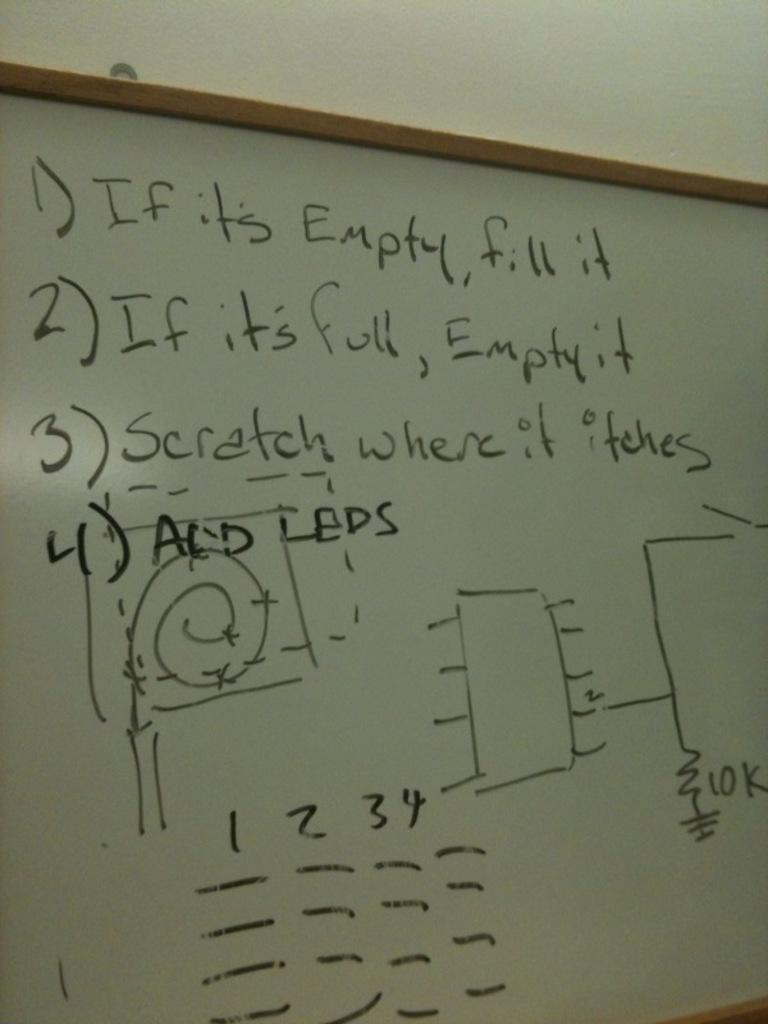<image>
Give a short and clear explanation of the subsequent image. A white board that has instructions, including a rule that if it's empty, fill it. 